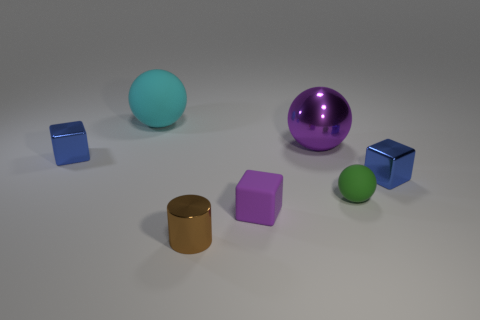There is a shiny block right of the small green thing; is it the same size as the metallic object on the left side of the brown metal cylinder?
Your answer should be compact. Yes. There is a matte thing behind the tiny blue metal object that is on the right side of the cyan rubber thing; what shape is it?
Keep it short and to the point. Sphere. Are there an equal number of tiny green rubber objects to the left of the matte cube and big green matte balls?
Your response must be concise. Yes. There is a sphere that is in front of the metal block that is left of the blue metal block that is to the right of the small green thing; what is it made of?
Provide a succinct answer. Rubber. Are there any shiny blocks of the same size as the purple rubber block?
Provide a succinct answer. Yes. There is a big metallic object; what shape is it?
Provide a short and direct response. Sphere. How many blocks are small brown things or blue shiny objects?
Your answer should be compact. 2. Are there an equal number of large cyan matte things that are in front of the tiny cylinder and green objects that are to the left of the tiny green ball?
Your answer should be compact. Yes. There is a blue shiny thing that is to the left of the rubber ball behind the tiny green ball; how many small blue shiny blocks are in front of it?
Keep it short and to the point. 1. What shape is the large metal object that is the same color as the matte cube?
Offer a very short reply. Sphere. 